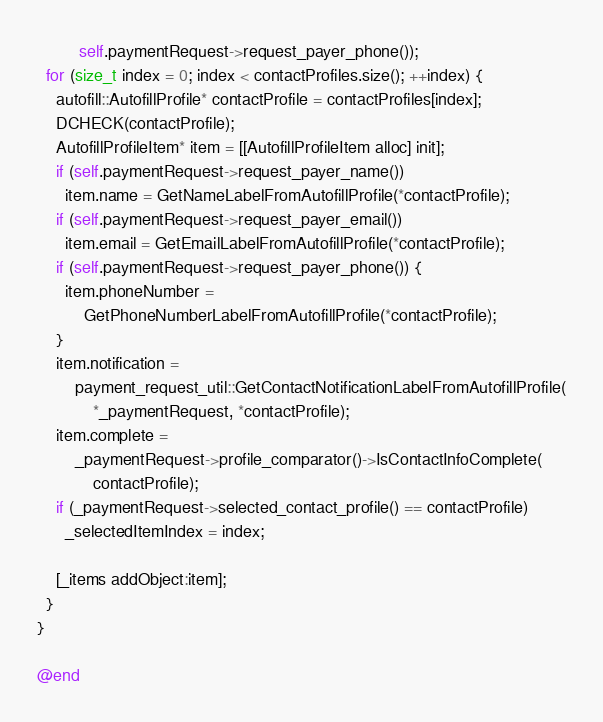Convert code to text. <code><loc_0><loc_0><loc_500><loc_500><_ObjectiveC_>         self.paymentRequest->request_payer_phone());
  for (size_t index = 0; index < contactProfiles.size(); ++index) {
    autofill::AutofillProfile* contactProfile = contactProfiles[index];
    DCHECK(contactProfile);
    AutofillProfileItem* item = [[AutofillProfileItem alloc] init];
    if (self.paymentRequest->request_payer_name())
      item.name = GetNameLabelFromAutofillProfile(*contactProfile);
    if (self.paymentRequest->request_payer_email())
      item.email = GetEmailLabelFromAutofillProfile(*contactProfile);
    if (self.paymentRequest->request_payer_phone()) {
      item.phoneNumber =
          GetPhoneNumberLabelFromAutofillProfile(*contactProfile);
    }
    item.notification =
        payment_request_util::GetContactNotificationLabelFromAutofillProfile(
            *_paymentRequest, *contactProfile);
    item.complete =
        _paymentRequest->profile_comparator()->IsContactInfoComplete(
            contactProfile);
    if (_paymentRequest->selected_contact_profile() == contactProfile)
      _selectedItemIndex = index;

    [_items addObject:item];
  }
}

@end
</code> 